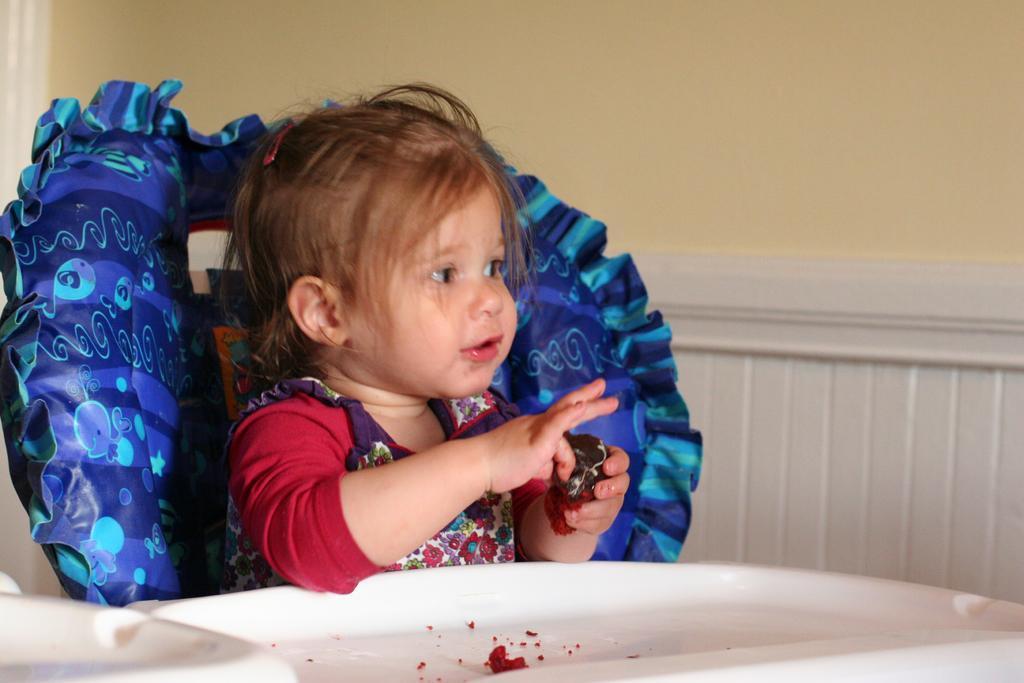How would you summarize this image in a sentence or two? This picture is clicked inside. On the left there is a kid wearing t-shirt, holding some food item and sitting on a blue color inflatable chair. In the foreground there are some objects placed on the top of the table. In the background there is a wall. 